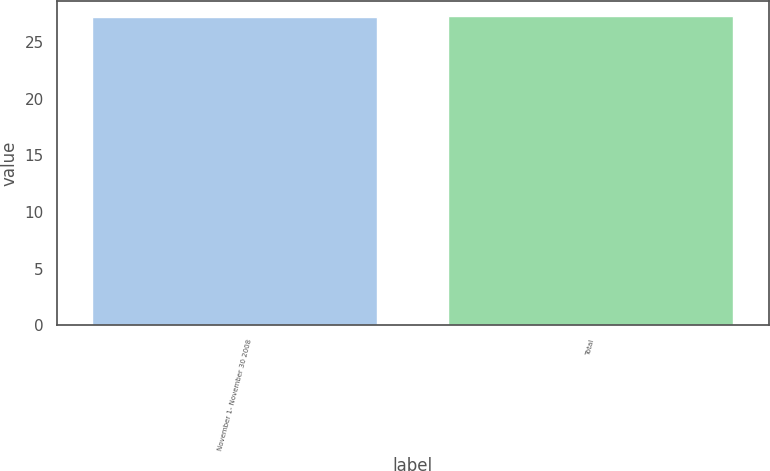Convert chart to OTSL. <chart><loc_0><loc_0><loc_500><loc_500><bar_chart><fcel>November 1- November 30 2008<fcel>Total<nl><fcel>27.17<fcel>27.27<nl></chart> 